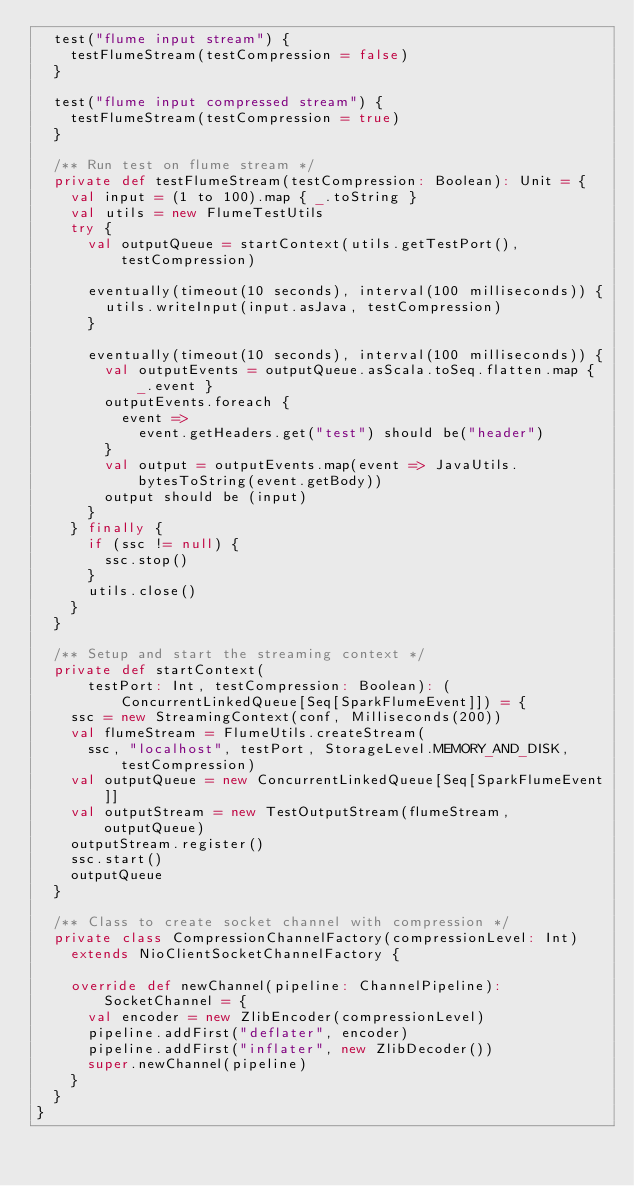<code> <loc_0><loc_0><loc_500><loc_500><_Scala_>  test("flume input stream") {
    testFlumeStream(testCompression = false)
  }

  test("flume input compressed stream") {
    testFlumeStream(testCompression = true)
  }

  /** Run test on flume stream */
  private def testFlumeStream(testCompression: Boolean): Unit = {
    val input = (1 to 100).map { _.toString }
    val utils = new FlumeTestUtils
    try {
      val outputQueue = startContext(utils.getTestPort(), testCompression)

      eventually(timeout(10 seconds), interval(100 milliseconds)) {
        utils.writeInput(input.asJava, testCompression)
      }

      eventually(timeout(10 seconds), interval(100 milliseconds)) {
        val outputEvents = outputQueue.asScala.toSeq.flatten.map { _.event }
        outputEvents.foreach {
          event =>
            event.getHeaders.get("test") should be("header")
        }
        val output = outputEvents.map(event => JavaUtils.bytesToString(event.getBody))
        output should be (input)
      }
    } finally {
      if (ssc != null) {
        ssc.stop()
      }
      utils.close()
    }
  }

  /** Setup and start the streaming context */
  private def startContext(
      testPort: Int, testCompression: Boolean): (ConcurrentLinkedQueue[Seq[SparkFlumeEvent]]) = {
    ssc = new StreamingContext(conf, Milliseconds(200))
    val flumeStream = FlumeUtils.createStream(
      ssc, "localhost", testPort, StorageLevel.MEMORY_AND_DISK, testCompression)
    val outputQueue = new ConcurrentLinkedQueue[Seq[SparkFlumeEvent]]
    val outputStream = new TestOutputStream(flumeStream, outputQueue)
    outputStream.register()
    ssc.start()
    outputQueue
  }

  /** Class to create socket channel with compression */
  private class CompressionChannelFactory(compressionLevel: Int)
    extends NioClientSocketChannelFactory {

    override def newChannel(pipeline: ChannelPipeline): SocketChannel = {
      val encoder = new ZlibEncoder(compressionLevel)
      pipeline.addFirst("deflater", encoder)
      pipeline.addFirst("inflater", new ZlibDecoder())
      super.newChannel(pipeline)
    }
  }
}
</code> 